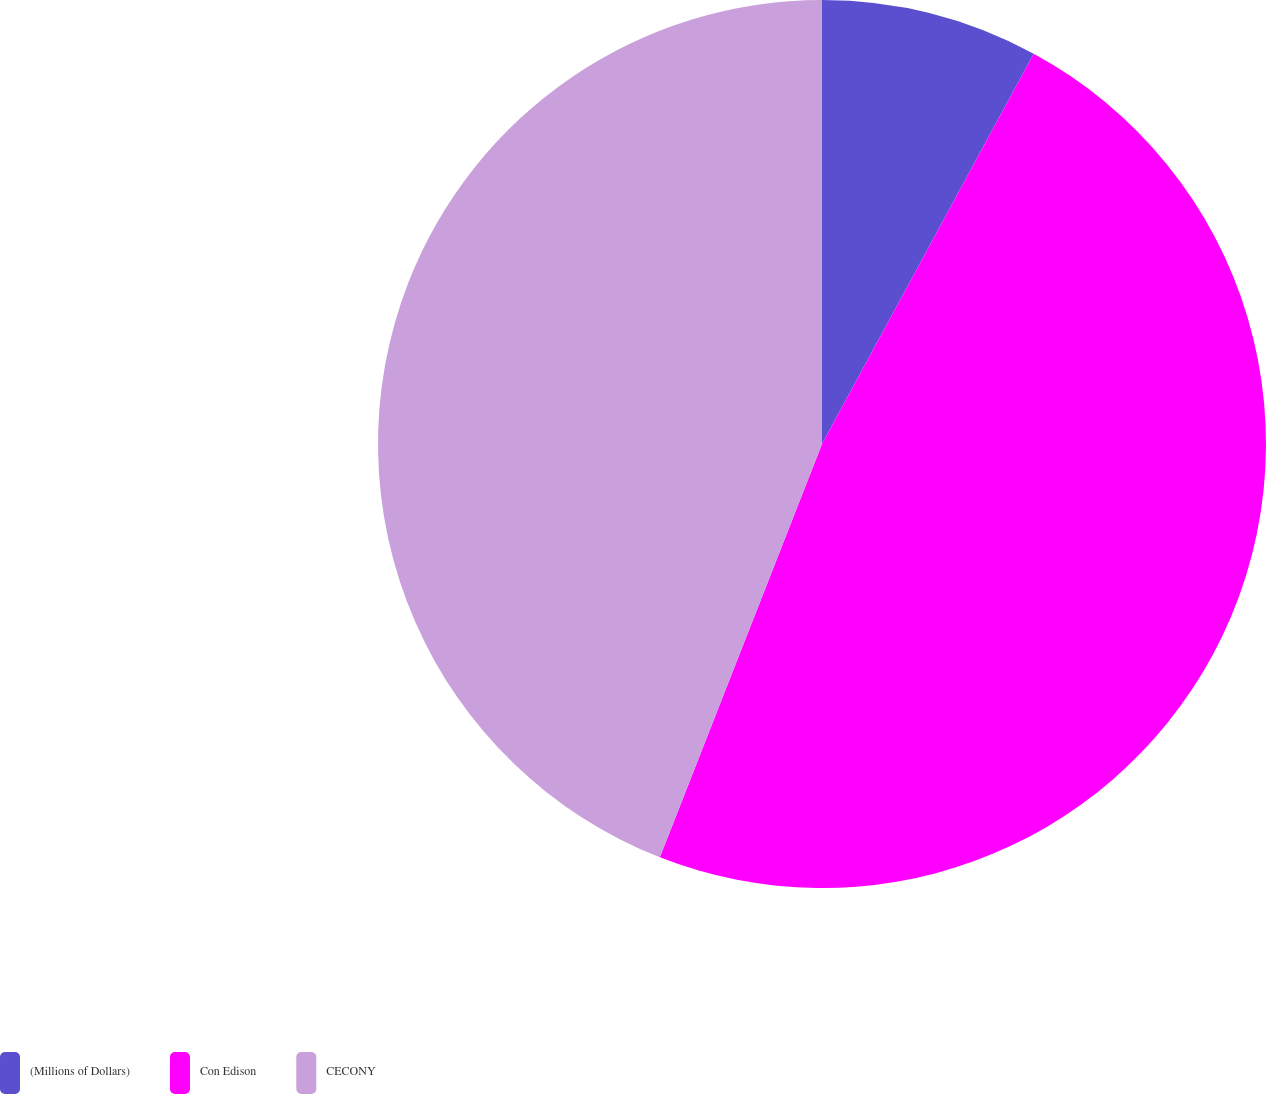Convert chart to OTSL. <chart><loc_0><loc_0><loc_500><loc_500><pie_chart><fcel>(Millions of Dollars)<fcel>Con Edison<fcel>CECONY<nl><fcel>7.91%<fcel>48.04%<fcel>44.05%<nl></chart> 